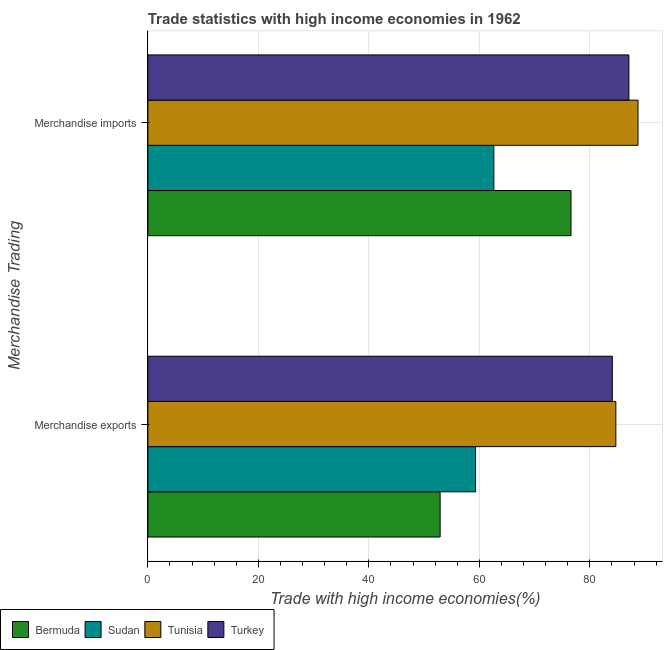How many different coloured bars are there?
Offer a very short reply. 4. What is the label of the 1st group of bars from the top?
Your response must be concise. Merchandise imports. What is the merchandise exports in Tunisia?
Keep it short and to the point. 84.7. Across all countries, what is the maximum merchandise imports?
Make the answer very short. 88.71. Across all countries, what is the minimum merchandise exports?
Offer a terse response. 52.9. In which country was the merchandise imports maximum?
Provide a short and direct response. Tunisia. In which country was the merchandise imports minimum?
Your answer should be very brief. Sudan. What is the total merchandise imports in the graph?
Provide a short and direct response. 314.98. What is the difference between the merchandise imports in Turkey and that in Tunisia?
Ensure brevity in your answer.  -1.64. What is the difference between the merchandise imports in Tunisia and the merchandise exports in Bermuda?
Make the answer very short. 35.81. What is the average merchandise imports per country?
Provide a succinct answer. 78.74. What is the difference between the merchandise exports and merchandise imports in Tunisia?
Your answer should be very brief. -4.01. What is the ratio of the merchandise imports in Tunisia to that in Bermuda?
Ensure brevity in your answer.  1.16. In how many countries, is the merchandise imports greater than the average merchandise imports taken over all countries?
Ensure brevity in your answer.  2. What does the 2nd bar from the top in Merchandise exports represents?
Provide a short and direct response. Tunisia. What does the 3rd bar from the bottom in Merchandise exports represents?
Offer a terse response. Tunisia. Are all the bars in the graph horizontal?
Keep it short and to the point. Yes. What is the difference between two consecutive major ticks on the X-axis?
Offer a terse response. 20. Are the values on the major ticks of X-axis written in scientific E-notation?
Provide a succinct answer. No. Does the graph contain grids?
Your answer should be compact. Yes. Where does the legend appear in the graph?
Make the answer very short. Bottom left. What is the title of the graph?
Provide a succinct answer. Trade statistics with high income economies in 1962. What is the label or title of the X-axis?
Keep it short and to the point. Trade with high income economies(%). What is the label or title of the Y-axis?
Your answer should be very brief. Merchandise Trading. What is the Trade with high income economies(%) of Bermuda in Merchandise exports?
Ensure brevity in your answer.  52.9. What is the Trade with high income economies(%) of Sudan in Merchandise exports?
Your response must be concise. 59.31. What is the Trade with high income economies(%) in Tunisia in Merchandise exports?
Offer a terse response. 84.7. What is the Trade with high income economies(%) in Turkey in Merchandise exports?
Offer a very short reply. 84.06. What is the Trade with high income economies(%) of Bermuda in Merchandise imports?
Your answer should be very brief. 76.58. What is the Trade with high income economies(%) in Sudan in Merchandise imports?
Offer a very short reply. 62.62. What is the Trade with high income economies(%) of Tunisia in Merchandise imports?
Offer a very short reply. 88.71. What is the Trade with high income economies(%) in Turkey in Merchandise imports?
Offer a terse response. 87.07. Across all Merchandise Trading, what is the maximum Trade with high income economies(%) of Bermuda?
Give a very brief answer. 76.58. Across all Merchandise Trading, what is the maximum Trade with high income economies(%) in Sudan?
Ensure brevity in your answer.  62.62. Across all Merchandise Trading, what is the maximum Trade with high income economies(%) of Tunisia?
Ensure brevity in your answer.  88.71. Across all Merchandise Trading, what is the maximum Trade with high income economies(%) of Turkey?
Offer a terse response. 87.07. Across all Merchandise Trading, what is the minimum Trade with high income economies(%) of Bermuda?
Offer a terse response. 52.9. Across all Merchandise Trading, what is the minimum Trade with high income economies(%) in Sudan?
Offer a terse response. 59.31. Across all Merchandise Trading, what is the minimum Trade with high income economies(%) of Tunisia?
Your answer should be very brief. 84.7. Across all Merchandise Trading, what is the minimum Trade with high income economies(%) in Turkey?
Give a very brief answer. 84.06. What is the total Trade with high income economies(%) in Bermuda in the graph?
Keep it short and to the point. 129.48. What is the total Trade with high income economies(%) of Sudan in the graph?
Provide a short and direct response. 121.93. What is the total Trade with high income economies(%) in Tunisia in the graph?
Offer a terse response. 173.41. What is the total Trade with high income economies(%) in Turkey in the graph?
Make the answer very short. 171.13. What is the difference between the Trade with high income economies(%) in Bermuda in Merchandise exports and that in Merchandise imports?
Give a very brief answer. -23.69. What is the difference between the Trade with high income economies(%) in Sudan in Merchandise exports and that in Merchandise imports?
Give a very brief answer. -3.31. What is the difference between the Trade with high income economies(%) in Tunisia in Merchandise exports and that in Merchandise imports?
Make the answer very short. -4.01. What is the difference between the Trade with high income economies(%) in Turkey in Merchandise exports and that in Merchandise imports?
Offer a very short reply. -3. What is the difference between the Trade with high income economies(%) in Bermuda in Merchandise exports and the Trade with high income economies(%) in Sudan in Merchandise imports?
Your answer should be very brief. -9.73. What is the difference between the Trade with high income economies(%) of Bermuda in Merchandise exports and the Trade with high income economies(%) of Tunisia in Merchandise imports?
Keep it short and to the point. -35.81. What is the difference between the Trade with high income economies(%) in Bermuda in Merchandise exports and the Trade with high income economies(%) in Turkey in Merchandise imports?
Your answer should be compact. -34.17. What is the difference between the Trade with high income economies(%) of Sudan in Merchandise exports and the Trade with high income economies(%) of Tunisia in Merchandise imports?
Offer a very short reply. -29.4. What is the difference between the Trade with high income economies(%) of Sudan in Merchandise exports and the Trade with high income economies(%) of Turkey in Merchandise imports?
Offer a terse response. -27.75. What is the difference between the Trade with high income economies(%) in Tunisia in Merchandise exports and the Trade with high income economies(%) in Turkey in Merchandise imports?
Your answer should be very brief. -2.36. What is the average Trade with high income economies(%) of Bermuda per Merchandise Trading?
Provide a short and direct response. 64.74. What is the average Trade with high income economies(%) in Sudan per Merchandise Trading?
Your answer should be very brief. 60.97. What is the average Trade with high income economies(%) of Tunisia per Merchandise Trading?
Ensure brevity in your answer.  86.7. What is the average Trade with high income economies(%) in Turkey per Merchandise Trading?
Keep it short and to the point. 85.57. What is the difference between the Trade with high income economies(%) in Bermuda and Trade with high income economies(%) in Sudan in Merchandise exports?
Make the answer very short. -6.42. What is the difference between the Trade with high income economies(%) of Bermuda and Trade with high income economies(%) of Tunisia in Merchandise exports?
Give a very brief answer. -31.81. What is the difference between the Trade with high income economies(%) of Bermuda and Trade with high income economies(%) of Turkey in Merchandise exports?
Ensure brevity in your answer.  -31.17. What is the difference between the Trade with high income economies(%) in Sudan and Trade with high income economies(%) in Tunisia in Merchandise exports?
Offer a terse response. -25.39. What is the difference between the Trade with high income economies(%) of Sudan and Trade with high income economies(%) of Turkey in Merchandise exports?
Your answer should be compact. -24.75. What is the difference between the Trade with high income economies(%) in Tunisia and Trade with high income economies(%) in Turkey in Merchandise exports?
Your answer should be very brief. 0.64. What is the difference between the Trade with high income economies(%) of Bermuda and Trade with high income economies(%) of Sudan in Merchandise imports?
Ensure brevity in your answer.  13.96. What is the difference between the Trade with high income economies(%) in Bermuda and Trade with high income economies(%) in Tunisia in Merchandise imports?
Your answer should be compact. -12.12. What is the difference between the Trade with high income economies(%) of Bermuda and Trade with high income economies(%) of Turkey in Merchandise imports?
Offer a very short reply. -10.48. What is the difference between the Trade with high income economies(%) of Sudan and Trade with high income economies(%) of Tunisia in Merchandise imports?
Your answer should be very brief. -26.09. What is the difference between the Trade with high income economies(%) of Sudan and Trade with high income economies(%) of Turkey in Merchandise imports?
Offer a terse response. -24.44. What is the difference between the Trade with high income economies(%) of Tunisia and Trade with high income economies(%) of Turkey in Merchandise imports?
Make the answer very short. 1.64. What is the ratio of the Trade with high income economies(%) in Bermuda in Merchandise exports to that in Merchandise imports?
Offer a very short reply. 0.69. What is the ratio of the Trade with high income economies(%) in Sudan in Merchandise exports to that in Merchandise imports?
Ensure brevity in your answer.  0.95. What is the ratio of the Trade with high income economies(%) in Tunisia in Merchandise exports to that in Merchandise imports?
Your answer should be compact. 0.95. What is the ratio of the Trade with high income economies(%) in Turkey in Merchandise exports to that in Merchandise imports?
Keep it short and to the point. 0.97. What is the difference between the highest and the second highest Trade with high income economies(%) in Bermuda?
Ensure brevity in your answer.  23.69. What is the difference between the highest and the second highest Trade with high income economies(%) of Sudan?
Provide a short and direct response. 3.31. What is the difference between the highest and the second highest Trade with high income economies(%) of Tunisia?
Make the answer very short. 4.01. What is the difference between the highest and the second highest Trade with high income economies(%) in Turkey?
Offer a very short reply. 3. What is the difference between the highest and the lowest Trade with high income economies(%) in Bermuda?
Make the answer very short. 23.69. What is the difference between the highest and the lowest Trade with high income economies(%) in Sudan?
Offer a terse response. 3.31. What is the difference between the highest and the lowest Trade with high income economies(%) of Tunisia?
Provide a short and direct response. 4.01. What is the difference between the highest and the lowest Trade with high income economies(%) in Turkey?
Provide a short and direct response. 3. 